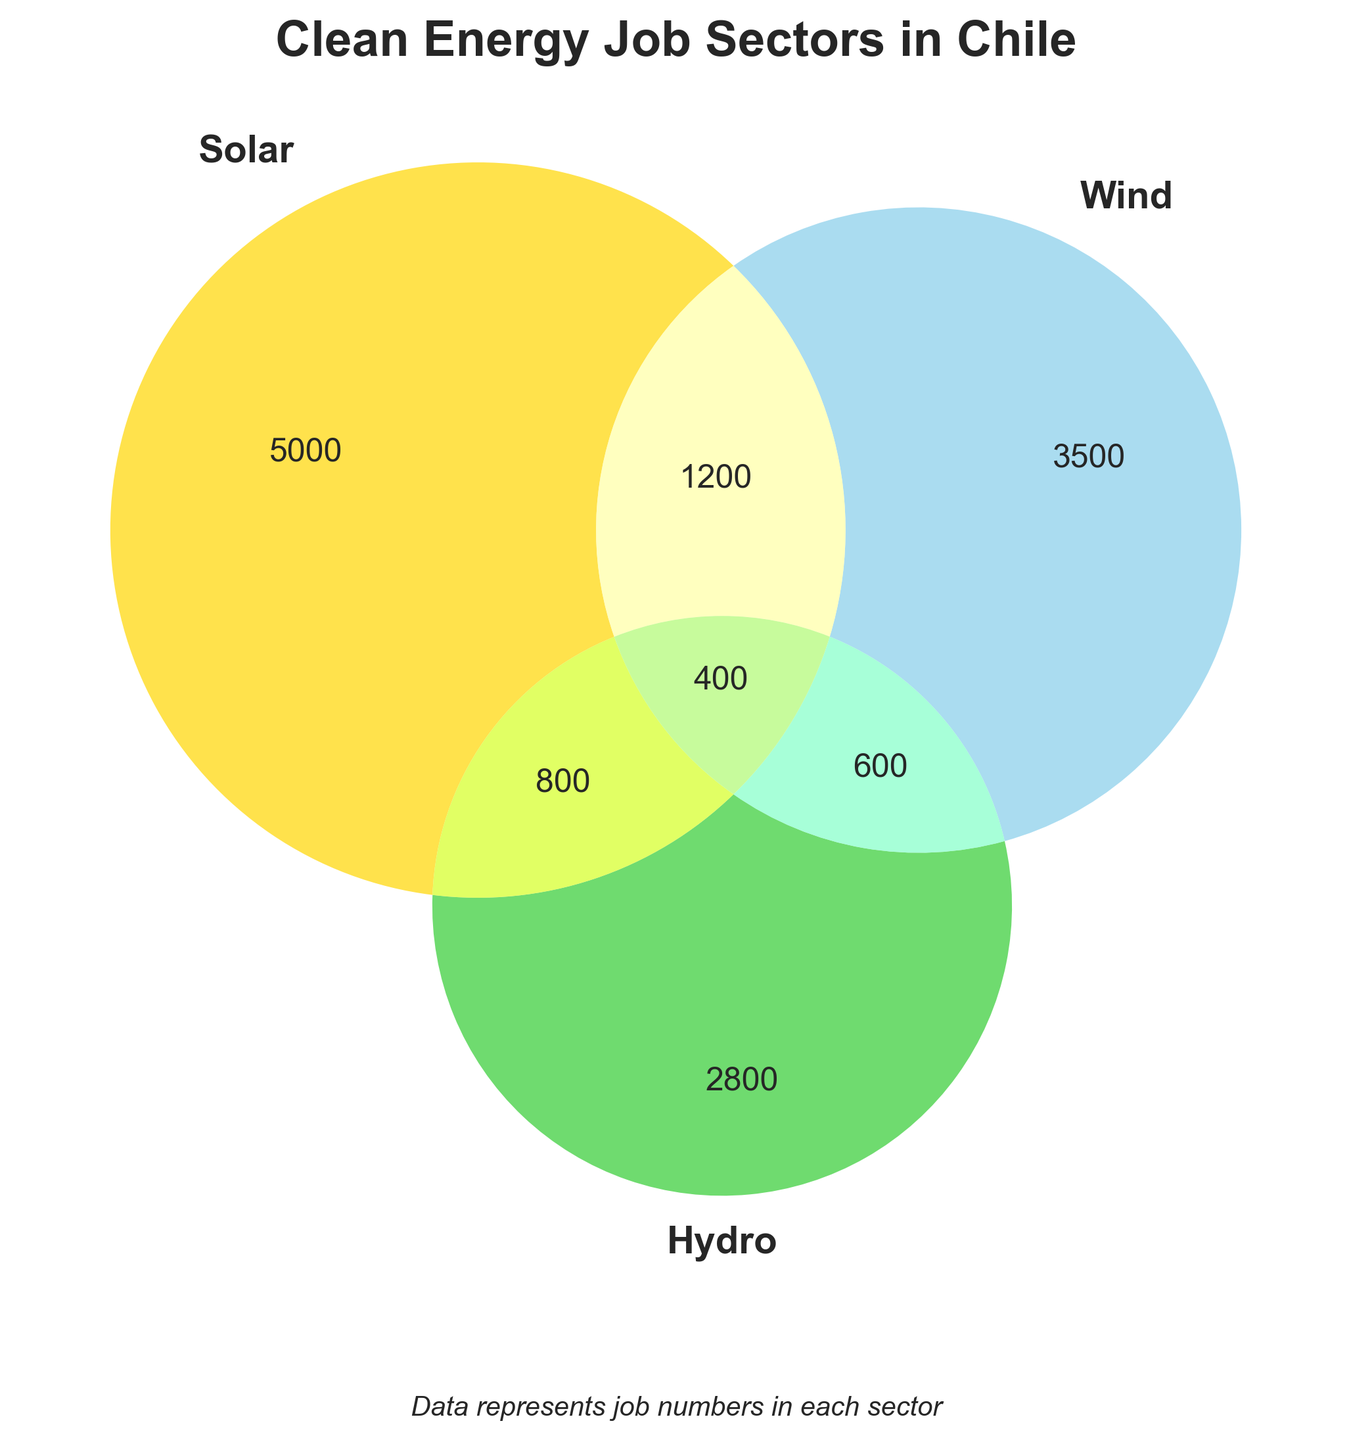How many jobs are there in the Solar sector? The 'Solar' subset shows there are 5000 jobs in this sector.
Answer: 5000 How many jobs are exclusive to the Wind sector? The 'Wind' subset shows there are 3500 jobs that are exclusive to this sector.
Answer: 3500 What is the total number of jobs in both the Solar and Wind sectors combined? Adding jobs from Solar (5000), Wind (3500), and their intersection (1200): 5000 + 3500 + 1200
Answer: 9700 Are there more jobs in the Hydroelectric sector or in the intersection of Solar and Wind? Hydroelectric has 2800 jobs while Solar+Wind has 1200 jobs. Clearly, Hydroelectric has more jobs.
Answer: Hydroelectric What portion of Solar jobs also involve Wind energy? 1200 jobs involve both Solar and Wind. Since Solar has 5000 jobs, the portion is (1200/5000) x 100.
Answer: 24% What is the combined number of jobs involving all three sectors? The intersection of Solar, Wind, and Hydroelectric shows 400 jobs involve all three sectors.
Answer: 400 How many jobs are shared between Wind and Hydroelectric sectors only? The 'Wind+Hydroelectric' subset shows there are 600 jobs shared between these two sectors.
Answer: 600 Is the number of jobs in Solar+Hydroelectric greater than in Wind+Hydroelectric? Solar+Hydroelectric has 800 jobs, while Wind+Hydroelectric has 600 jobs. Therefore, Solar+Hydroelectric has more jobs.
Answer: Yes Which sector or combination has the fewest jobs? The intersection of all three sectors (Solar+Wind+Hydroelectric) has the fewest jobs with 400.
Answer: Solar+Wind+Hydroelectric Calculate the total number of clean energy jobs across all sectors. Sum of all jobs: Solar (5000) + Wind (3500) + Hydroelectric (2800) + Solar+Wind (1200) + Solar+Hydroelectric (800) + Wind+Hydroelectric (600) + Solar+Wind+Hydroelectric (400)
Answer: 14300 